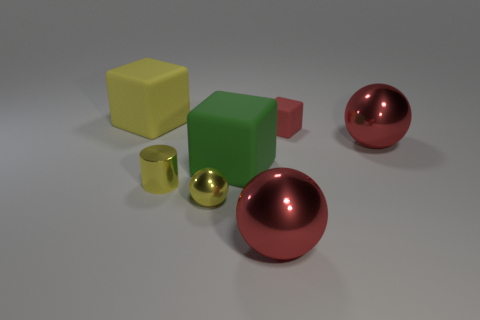Is there a small red object that has the same shape as the green rubber object?
Ensure brevity in your answer.  Yes. Are there any small red objects that are to the left of the large cube right of the large yellow rubber block?
Your answer should be very brief. No. How many objects have the same material as the small ball?
Ensure brevity in your answer.  3. Are there any red metal spheres?
Make the answer very short. Yes. What number of large things have the same color as the cylinder?
Offer a very short reply. 1. Is the tiny red cube made of the same material as the yellow object to the left of the cylinder?
Provide a short and direct response. Yes. Are there more large green blocks that are behind the green block than large brown matte balls?
Offer a terse response. No. Is there any other thing that has the same size as the yellow shiny sphere?
Offer a terse response. Yes. There is a small rubber object; does it have the same color as the big metal thing on the right side of the red rubber thing?
Your response must be concise. Yes. Are there an equal number of yellow matte cubes to the left of the large yellow matte thing and big cubes in front of the red matte cube?
Provide a succinct answer. No. 